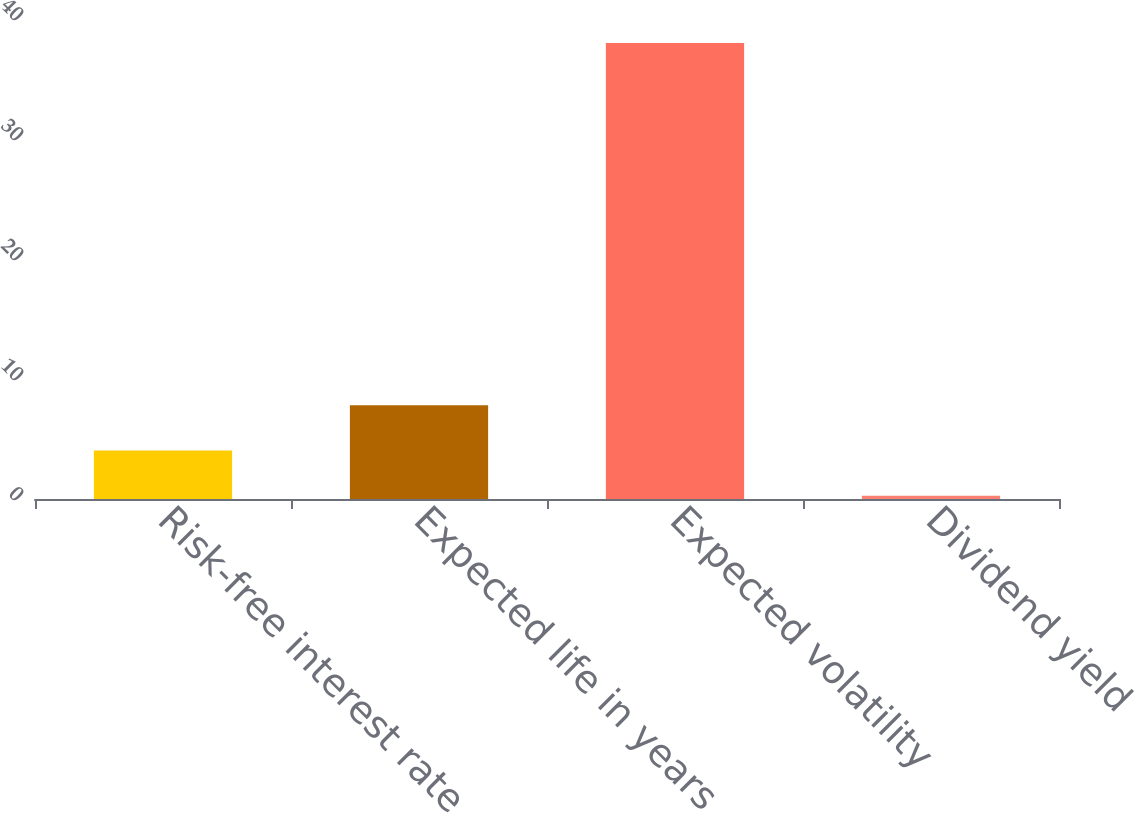Convert chart to OTSL. <chart><loc_0><loc_0><loc_500><loc_500><bar_chart><fcel>Risk-free interest rate<fcel>Expected life in years<fcel>Expected volatility<fcel>Dividend yield<nl><fcel>4.04<fcel>7.81<fcel>38<fcel>0.27<nl></chart> 